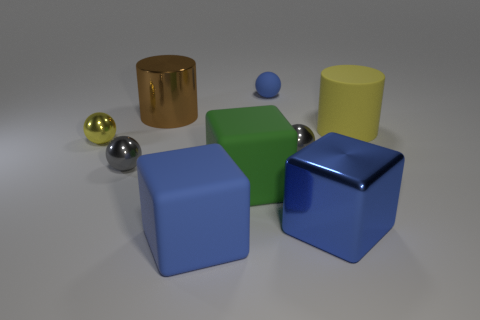What material is the ball that is the same color as the big metallic cube?
Offer a terse response. Rubber. What material is the object that is behind the metallic object behind the tiny yellow thing made of?
Offer a terse response. Rubber. Are there any large blue matte things that have the same shape as the big blue metallic object?
Your answer should be compact. Yes. Is the size of the blue matte ball the same as the blue matte thing in front of the tiny yellow metallic object?
Provide a succinct answer. No. What number of things are tiny gray metal spheres to the right of the big metal cylinder or gray objects that are on the right side of the large blue rubber thing?
Ensure brevity in your answer.  1. Are there more metallic cubes that are to the right of the big brown thing than tiny brown spheres?
Make the answer very short. Yes. What number of purple objects have the same size as the blue metallic thing?
Offer a terse response. 0. Is the size of the gray metallic thing that is on the right side of the blue rubber ball the same as the blue matte object in front of the yellow shiny ball?
Your answer should be compact. No. What size is the yellow object that is behind the yellow metallic ball?
Offer a terse response. Large. There is a blue rubber thing in front of the small gray metallic sphere that is to the left of the large brown metal cylinder; what is its size?
Offer a terse response. Large. 